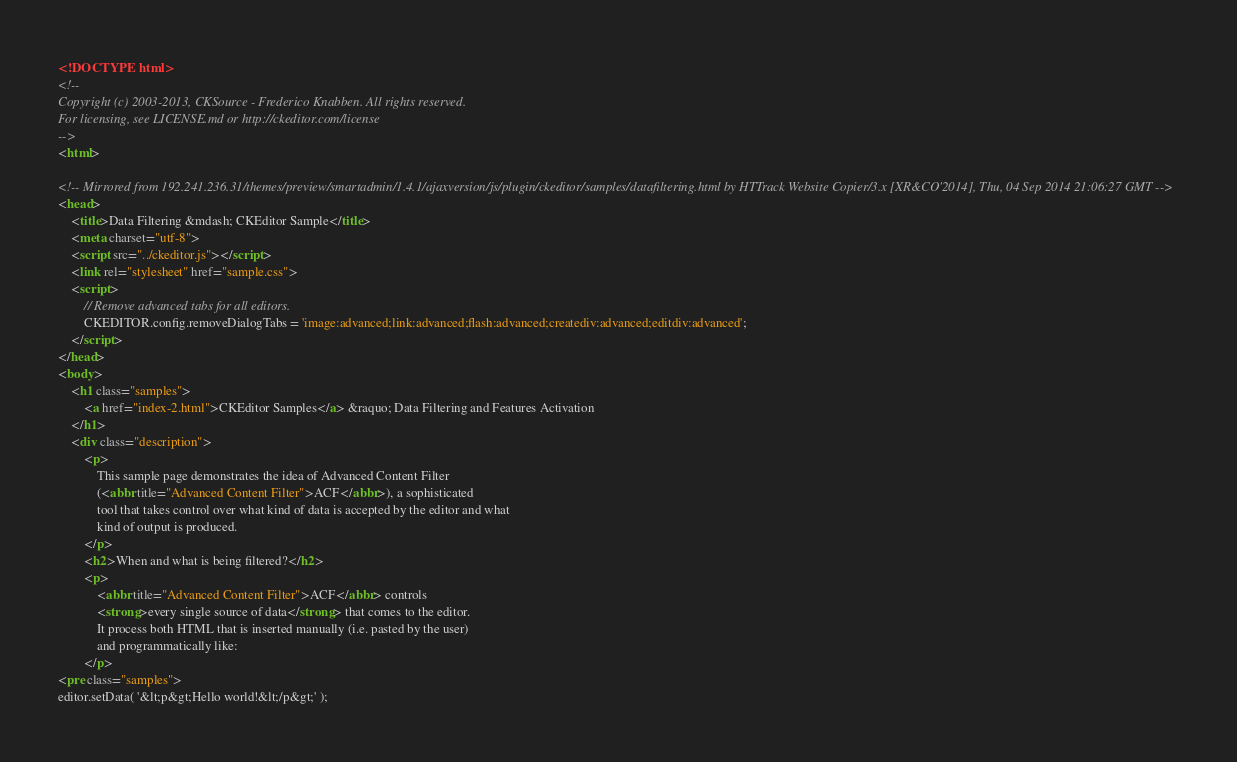Convert code to text. <code><loc_0><loc_0><loc_500><loc_500><_HTML_><!DOCTYPE html>
<!--
Copyright (c) 2003-2013, CKSource - Frederico Knabben. All rights reserved.
For licensing, see LICENSE.md or http://ckeditor.com/license
-->
<html>

<!-- Mirrored from 192.241.236.31/themes/preview/smartadmin/1.4.1/ajaxversion/js/plugin/ckeditor/samples/datafiltering.html by HTTrack Website Copier/3.x [XR&CO'2014], Thu, 04 Sep 2014 21:06:27 GMT -->
<head>
	<title>Data Filtering &mdash; CKEditor Sample</title>
	<meta charset="utf-8">
	<script src="../ckeditor.js"></script>
	<link rel="stylesheet" href="sample.css">
	<script>
		// Remove advanced tabs for all editors.
		CKEDITOR.config.removeDialogTabs = 'image:advanced;link:advanced;flash:advanced;creatediv:advanced;editdiv:advanced';
	</script>
</head>
<body>
	<h1 class="samples">
		<a href="index-2.html">CKEditor Samples</a> &raquo; Data Filtering and Features Activation
	</h1>
	<div class="description">
		<p>
			This sample page demonstrates the idea of Advanced Content Filter
			(<abbr title="Advanced Content Filter">ACF</abbr>), a sophisticated
			tool that takes control over what kind of data is accepted by the editor and what
			kind of output is produced.
		</p>
		<h2>When and what is being filtered?</h2>
		<p>
			<abbr title="Advanced Content Filter">ACF</abbr> controls
			<strong>every single source of data</strong> that comes to the editor.
			It process both HTML that is inserted manually (i.e. pasted by the user)
			and programmatically like:
		</p>
<pre class="samples">
editor.setData( '&lt;p&gt;Hello world!&lt;/p&gt;' );</code> 